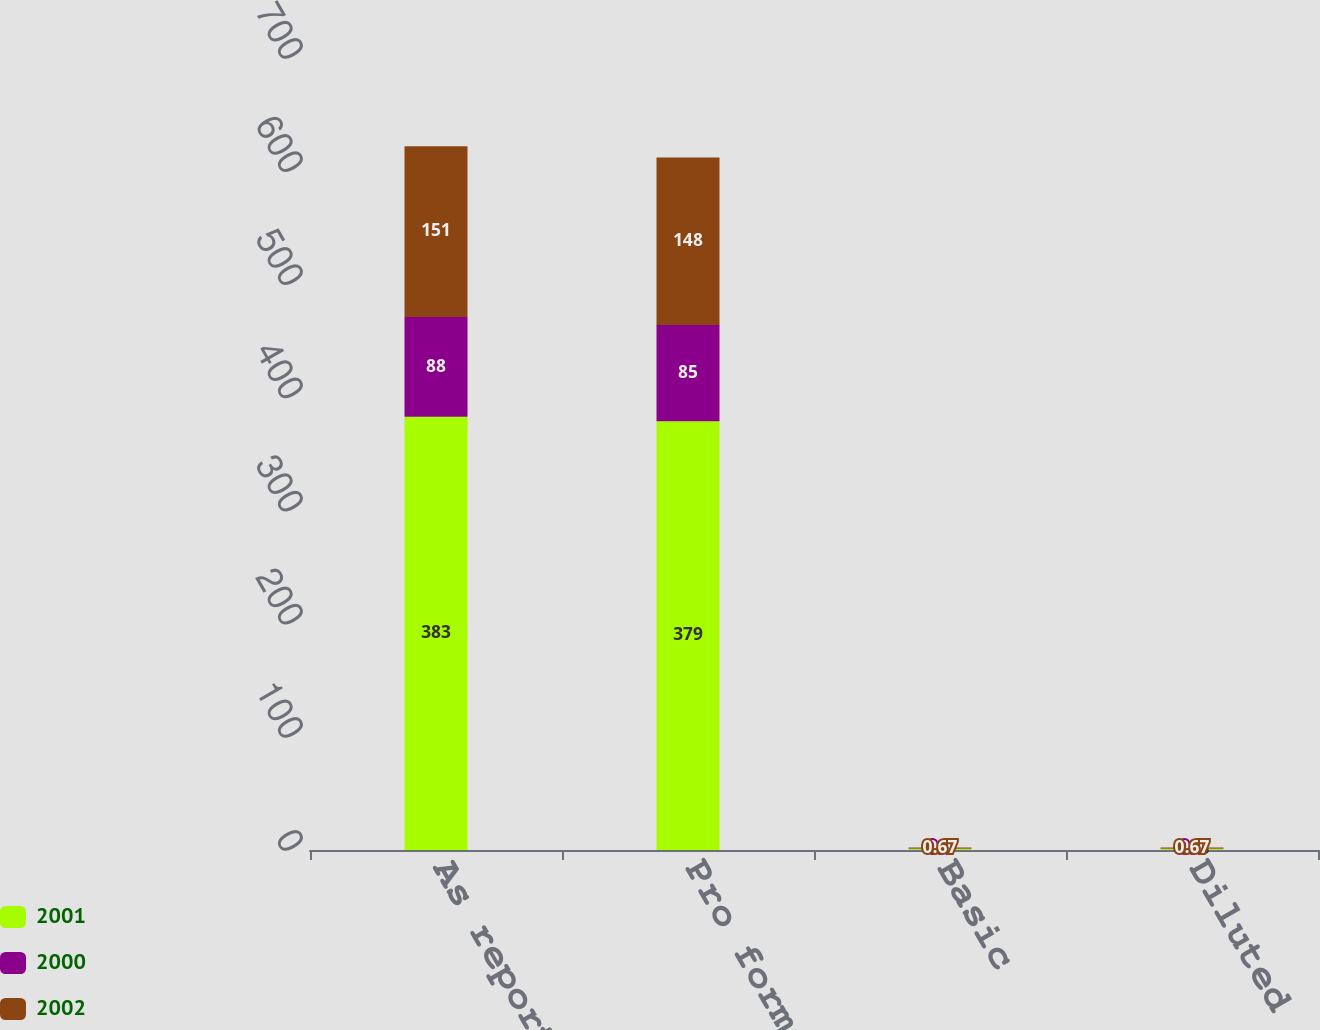Convert chart. <chart><loc_0><loc_0><loc_500><loc_500><stacked_bar_chart><ecel><fcel>As reported<fcel>Pro forma<fcel>Basic<fcel>Diluted<nl><fcel>2001<fcel>383<fcel>379<fcel>1.1<fcel>1.08<nl><fcel>2000<fcel>88<fcel>85<fcel>0.4<fcel>0.4<nl><fcel>2002<fcel>151<fcel>148<fcel>0.67<fcel>0.67<nl></chart> 